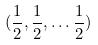<formula> <loc_0><loc_0><loc_500><loc_500>( \frac { 1 } { 2 } , \frac { 1 } { 2 } , \dots \frac { 1 } { 2 } )</formula> 